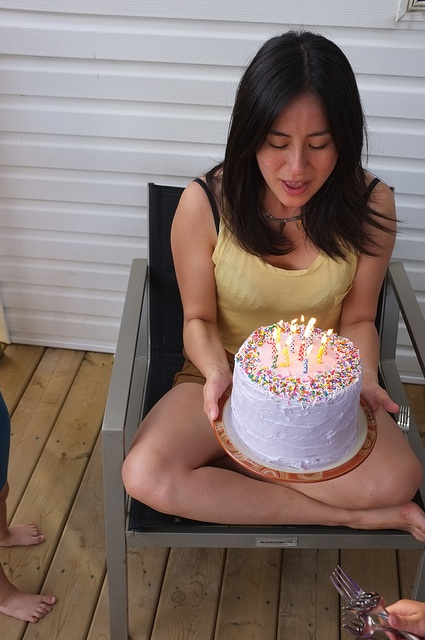Describe the objects in this image and their specific colors. I can see people in darkgray, brown, black, maroon, and tan tones, chair in darkgray, gray, and black tones, cake in darkgray, lavender, and lightpink tones, people in darkgray, gray, maroon, black, and brown tones, and people in darkgray, brown, maroon, and salmon tones in this image. 